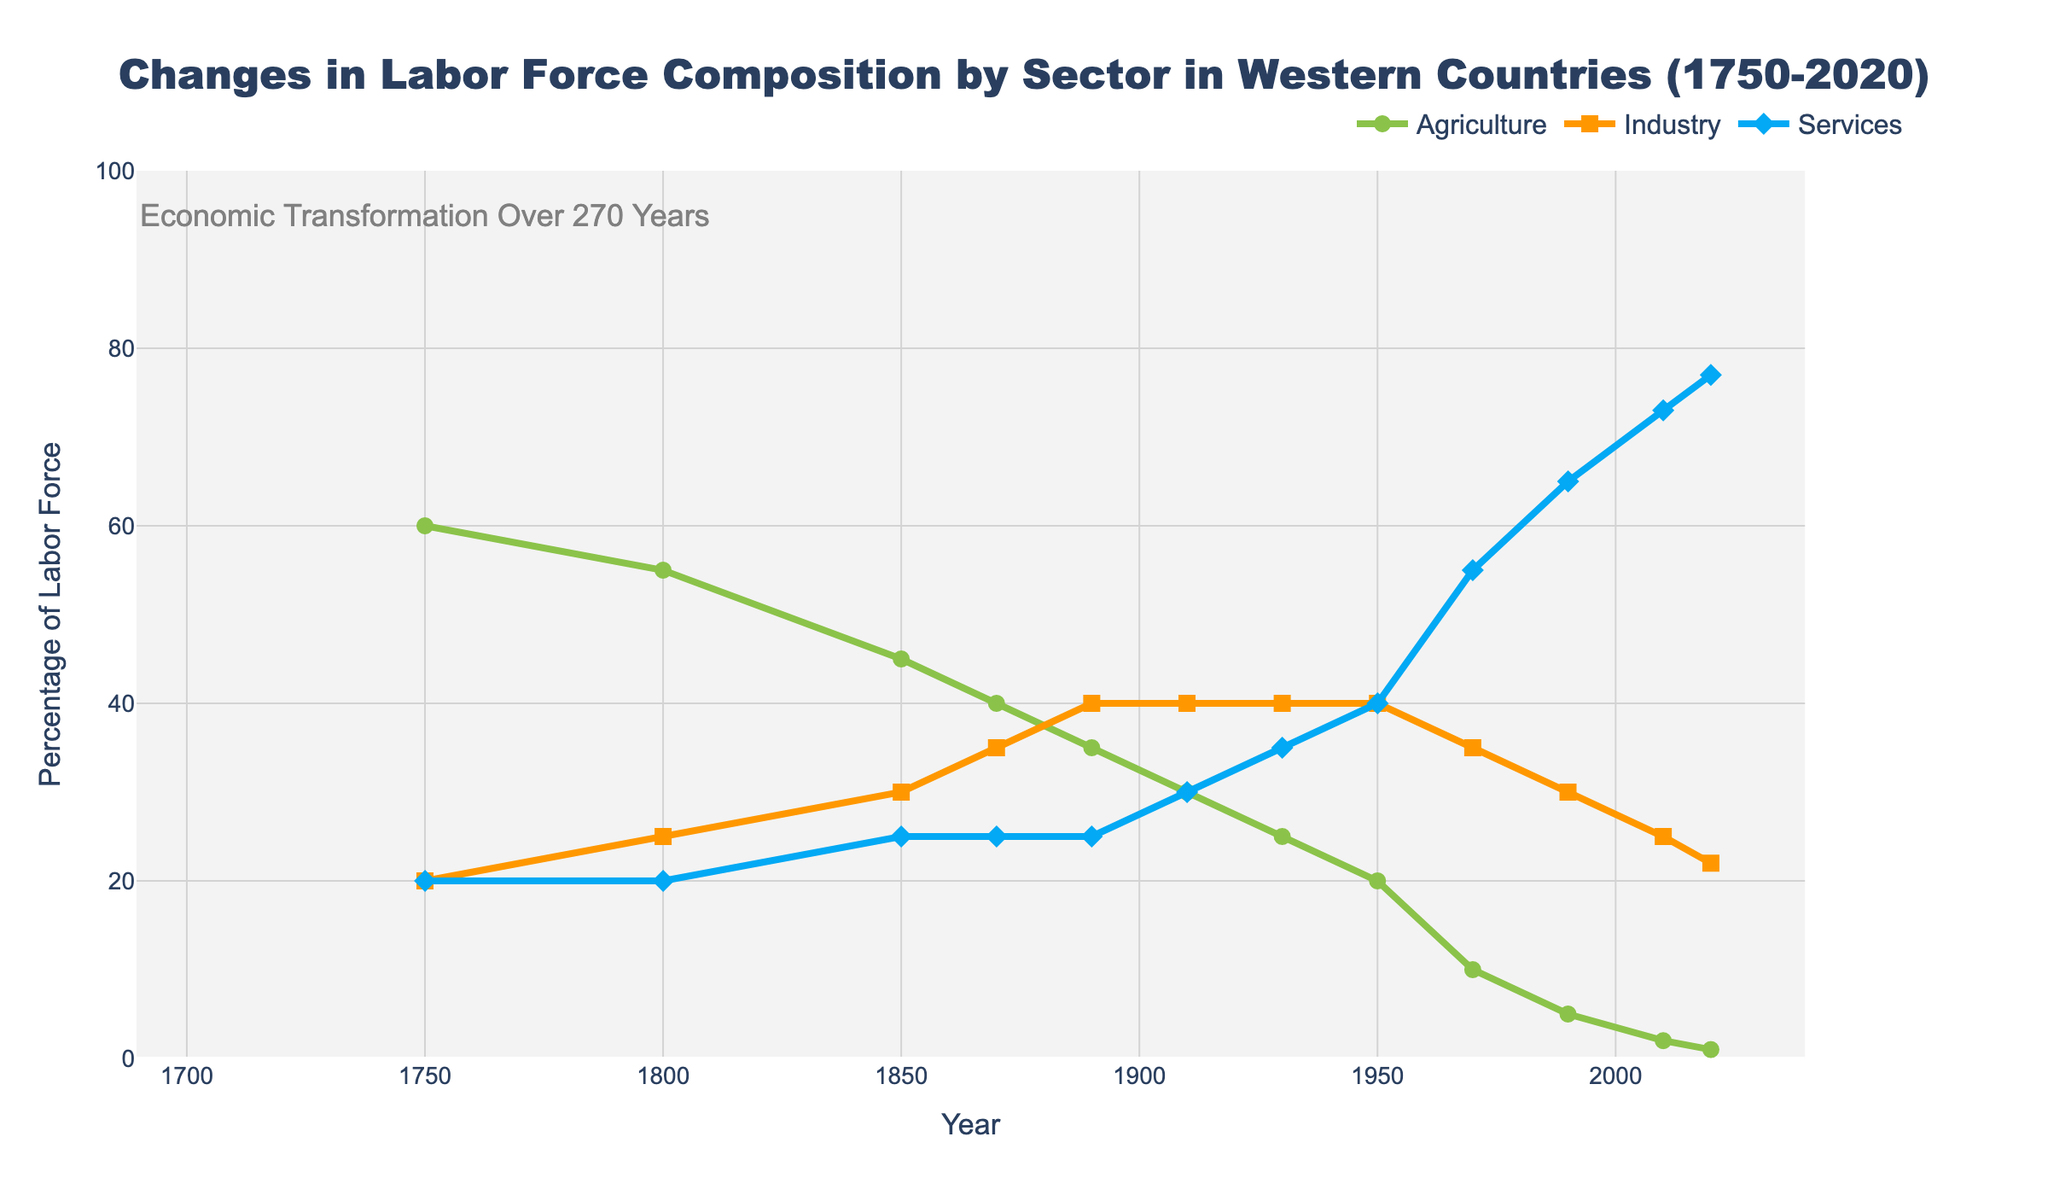what is the percentage difference between agriculture and services sectors in 1750? The percentage for the agriculture sector in 1750 is 60%, and for the services sector, it is 20%. The difference can be found by subtracting the percentage of services from the percentage of agriculture: 60% - 20% = 40%.
Answer: 40% Which sector had the highest percentage of the labor force in 1910? In 1910, the percentages for agriculture, industry, and services are 30%, 40%, and 30% respectively. Industry had the highest value at 40%.
Answer: Industry Which sector shows a continuous increase in its labor force percentage from 1750 to 2020? Observing the lines for each sector from 1750 to 2020, only the services sector shows a continuous increase, while agriculture and industry experience declines or fluctuations.
Answer: Services By how many percentage points did the industry sector's workforce change from 1850 to 1890? In 1850, the industry sector was 30%, and by 1890, it increased to 40%. The change is found by subtracting the two values: 40% - 30% = 10%.
Answer: 10% Is there a year where the percentage of labor force in agriculture and services are equal? Observing the lines for agriculture and services sectors, at no point do they intersect; thus, there is no year where their percentages are equal.
Answer: No Which sector had the smallest share of the labor force in 2020? Looking at the data for 2020, the percentages for agriculture, industry, and services are 1%, 22%, and 77% respectively. Agriculture has the smallest share.
Answer: Agriculture How does the percentage split between agriculture and industry in 1800 compare to that in 2020? In 1800, agriculture was at 55% and industry at 25%. In 2020, agriculture is at 1% and industry at 22%. Comparing the splits: Agriculture saw a decrease from 55% to 1%, while Industry saw a slight decrease from 25% to 22%.
Answer: Agriculture decreased; industry slightly decreased What's the overall trend in the industry sector's labor force percentage from 1750 to 2020? By examining the industry sector line, it initially increases from 20% in 1750 to 40% in 1890, stabilizes around 40% until 1950, then gradually starts to decrease to 22% by 2020.
Answer: First rising then falling Between which consecutive years did the services sector see the highest increase in labor force percentage? Looking at the increments for the services sector between each interval, the largest jump appears between 1950 (40%) and 1970 (55%), an increase of 15%.
Answer: 1950 to 1970 From the data provided, what role did the agriculture sector have in the labor force transition over the observed period? The agricultural sector shows a steady decline in percentage, starting from 60% in 1750 and decreasing to just 1% by 2020, highlighting a significant shift away from agriculture.
Answer: Steady decline 